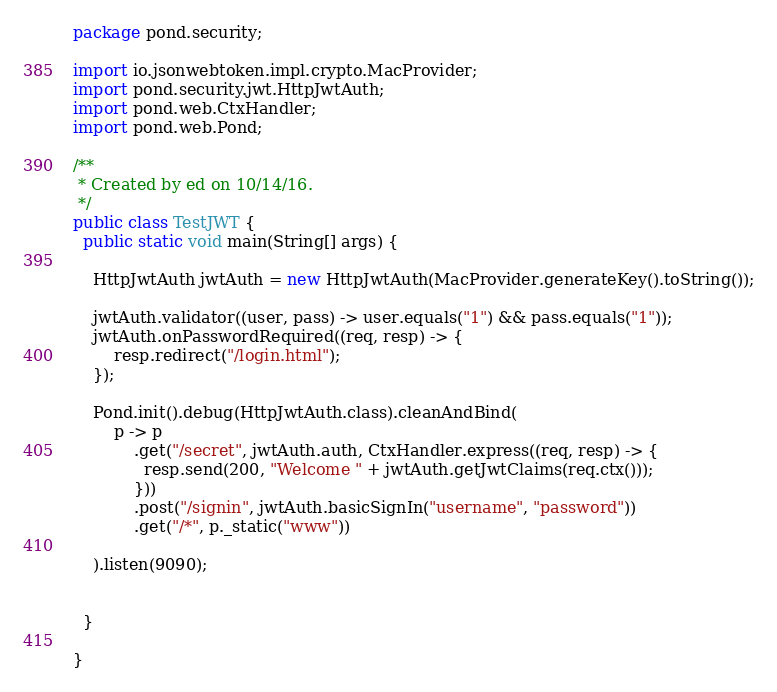<code> <loc_0><loc_0><loc_500><loc_500><_Java_>package pond.security;

import io.jsonwebtoken.impl.crypto.MacProvider;
import pond.security.jwt.HttpJwtAuth;
import pond.web.CtxHandler;
import pond.web.Pond;

/**
 * Created by ed on 10/14/16.
 */
public class TestJWT {
  public static void main(String[] args) {

    HttpJwtAuth jwtAuth = new HttpJwtAuth(MacProvider.generateKey().toString());

    jwtAuth.validator((user, pass) -> user.equals("1") && pass.equals("1"));
    jwtAuth.onPasswordRequired((req, resp) -> {
        resp.redirect("/login.html");
    });

    Pond.init().debug(HttpJwtAuth.class).cleanAndBind(
        p -> p
            .get("/secret", jwtAuth.auth, CtxHandler.express((req, resp) -> {
              resp.send(200, "Welcome " + jwtAuth.getJwtClaims(req.ctx()));
            }))
            .post("/signin", jwtAuth.basicSignIn("username", "password"))
            .get("/*", p._static("www"))

    ).listen(9090);


  }

}
</code> 